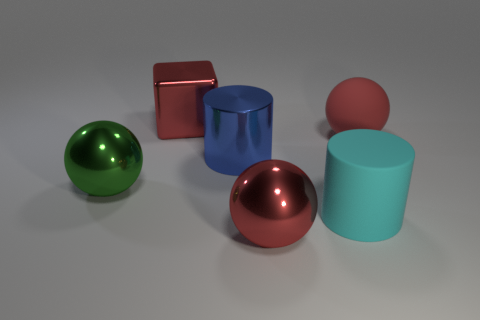Add 2 large cyan spheres. How many objects exist? 8 Subtract all red spheres. How many spheres are left? 1 Subtract all green balls. How many balls are left? 2 Subtract 1 cylinders. How many cylinders are left? 1 Subtract all cylinders. How many objects are left? 4 Subtract all purple blocks. Subtract all brown cylinders. How many blocks are left? 1 Subtract all cyan cubes. How many red spheres are left? 2 Subtract all blue metallic cylinders. Subtract all large green metal things. How many objects are left? 4 Add 4 blue shiny objects. How many blue shiny objects are left? 5 Add 3 large red metal cubes. How many large red metal cubes exist? 4 